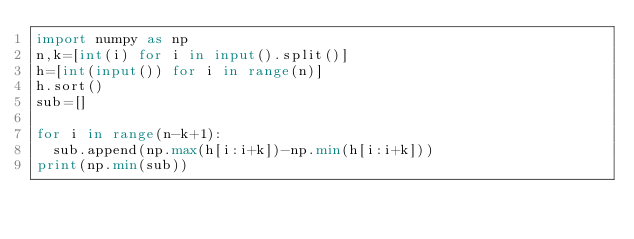Convert code to text. <code><loc_0><loc_0><loc_500><loc_500><_Python_>import numpy as np
n,k=[int(i) for i in input().split()]
h=[int(input()) for i in range(n)]
h.sort()
sub=[]

for i in range(n-k+1):
  sub.append(np.max(h[i:i+k])-np.min(h[i:i+k]))
print(np.min(sub))  
  
 </code> 